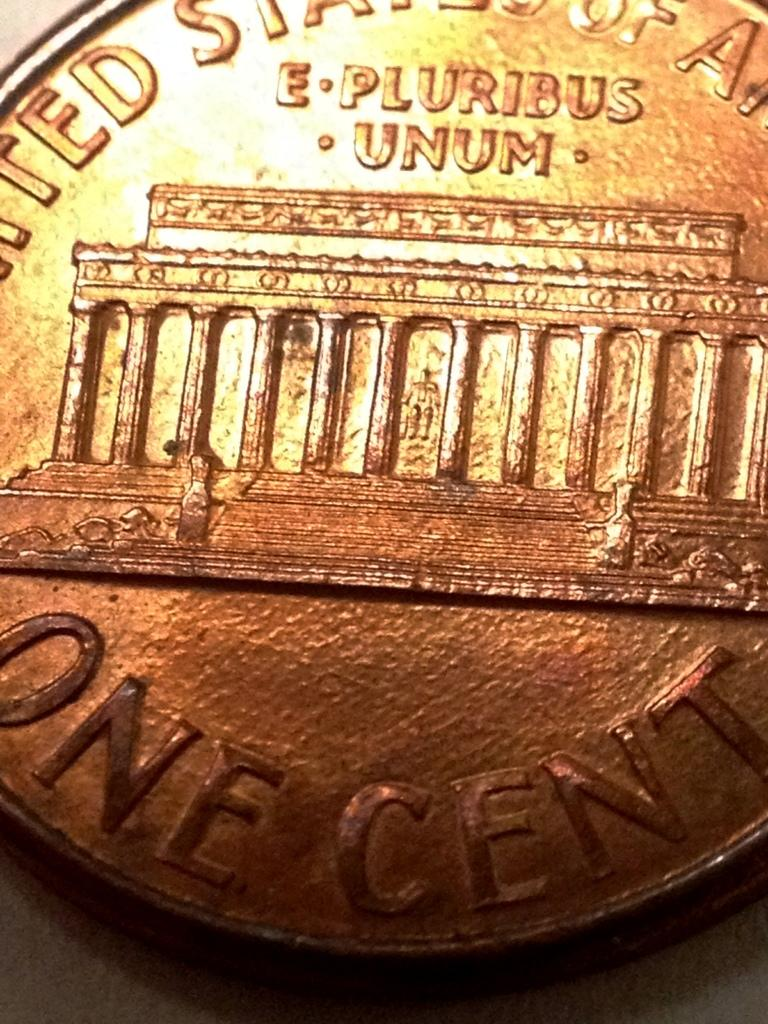<image>
Summarize the visual content of the image. The back of a United States one cent coin is shown. 